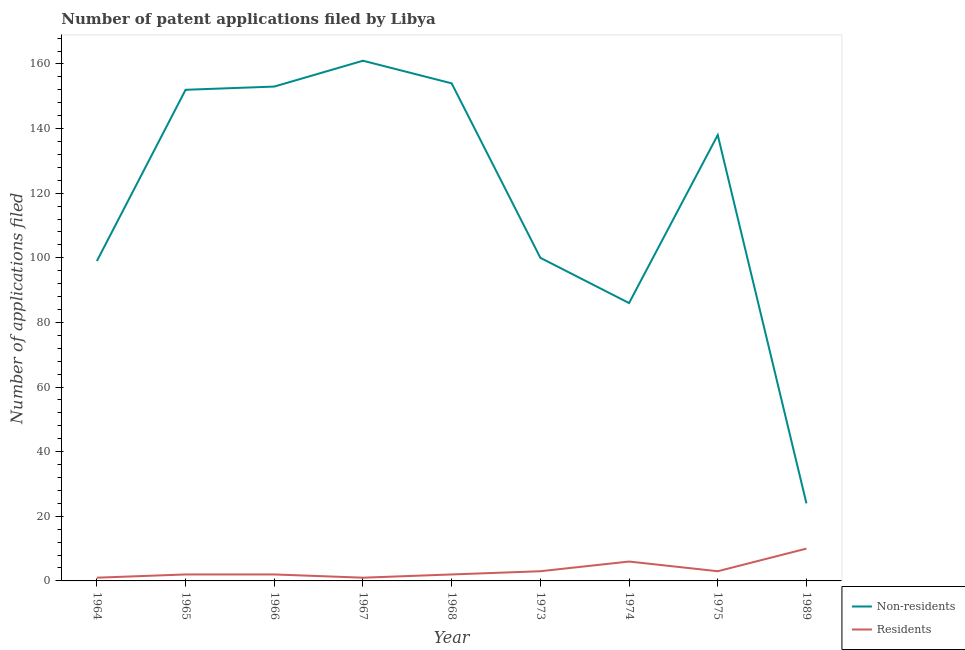How many different coloured lines are there?
Your answer should be compact. 2. Is the number of lines equal to the number of legend labels?
Offer a terse response. Yes. What is the number of patent applications by non residents in 1966?
Provide a short and direct response. 153. Across all years, what is the maximum number of patent applications by non residents?
Provide a succinct answer. 161. Across all years, what is the minimum number of patent applications by residents?
Provide a short and direct response. 1. In which year was the number of patent applications by non residents minimum?
Offer a very short reply. 1989. What is the total number of patent applications by residents in the graph?
Keep it short and to the point. 30. What is the difference between the number of patent applications by residents in 1966 and that in 1968?
Make the answer very short. 0. What is the difference between the number of patent applications by non residents in 1989 and the number of patent applications by residents in 1968?
Your answer should be compact. 22. What is the average number of patent applications by residents per year?
Give a very brief answer. 3.33. In the year 1965, what is the difference between the number of patent applications by non residents and number of patent applications by residents?
Provide a succinct answer. 150. What is the ratio of the number of patent applications by non residents in 1964 to that in 1974?
Your answer should be very brief. 1.15. Is the difference between the number of patent applications by residents in 1967 and 1974 greater than the difference between the number of patent applications by non residents in 1967 and 1974?
Your response must be concise. No. What is the difference between the highest and the second highest number of patent applications by residents?
Make the answer very short. 4. What is the difference between the highest and the lowest number of patent applications by non residents?
Your answer should be compact. 137. Is the sum of the number of patent applications by residents in 1964 and 1974 greater than the maximum number of patent applications by non residents across all years?
Your answer should be very brief. No. Does the number of patent applications by residents monotonically increase over the years?
Provide a succinct answer. No. Is the number of patent applications by residents strictly greater than the number of patent applications by non residents over the years?
Keep it short and to the point. No. Is the number of patent applications by non residents strictly less than the number of patent applications by residents over the years?
Your response must be concise. No. How many lines are there?
Provide a short and direct response. 2. How many years are there in the graph?
Provide a succinct answer. 9. How many legend labels are there?
Your answer should be very brief. 2. What is the title of the graph?
Provide a succinct answer. Number of patent applications filed by Libya. Does "Resident" appear as one of the legend labels in the graph?
Provide a succinct answer. No. What is the label or title of the Y-axis?
Provide a succinct answer. Number of applications filed. What is the Number of applications filed of Non-residents in 1964?
Keep it short and to the point. 99. What is the Number of applications filed of Residents in 1964?
Your answer should be compact. 1. What is the Number of applications filed of Non-residents in 1965?
Provide a succinct answer. 152. What is the Number of applications filed in Residents in 1965?
Provide a succinct answer. 2. What is the Number of applications filed in Non-residents in 1966?
Your answer should be very brief. 153. What is the Number of applications filed of Residents in 1966?
Your answer should be very brief. 2. What is the Number of applications filed in Non-residents in 1967?
Your answer should be compact. 161. What is the Number of applications filed of Residents in 1967?
Offer a terse response. 1. What is the Number of applications filed of Non-residents in 1968?
Ensure brevity in your answer.  154. What is the Number of applications filed in Residents in 1968?
Offer a terse response. 2. What is the Number of applications filed of Non-residents in 1973?
Offer a terse response. 100. What is the Number of applications filed in Residents in 1973?
Offer a very short reply. 3. What is the Number of applications filed in Residents in 1974?
Your answer should be very brief. 6. What is the Number of applications filed of Non-residents in 1975?
Provide a short and direct response. 138. What is the Number of applications filed in Residents in 1975?
Ensure brevity in your answer.  3. Across all years, what is the maximum Number of applications filed in Non-residents?
Give a very brief answer. 161. Across all years, what is the minimum Number of applications filed of Non-residents?
Keep it short and to the point. 24. What is the total Number of applications filed in Non-residents in the graph?
Give a very brief answer. 1067. What is the difference between the Number of applications filed of Non-residents in 1964 and that in 1965?
Provide a succinct answer. -53. What is the difference between the Number of applications filed in Residents in 1964 and that in 1965?
Make the answer very short. -1. What is the difference between the Number of applications filed of Non-residents in 1964 and that in 1966?
Provide a succinct answer. -54. What is the difference between the Number of applications filed in Residents in 1964 and that in 1966?
Give a very brief answer. -1. What is the difference between the Number of applications filed in Non-residents in 1964 and that in 1967?
Keep it short and to the point. -62. What is the difference between the Number of applications filed of Residents in 1964 and that in 1967?
Your answer should be very brief. 0. What is the difference between the Number of applications filed of Non-residents in 1964 and that in 1968?
Offer a very short reply. -55. What is the difference between the Number of applications filed of Residents in 1964 and that in 1968?
Provide a short and direct response. -1. What is the difference between the Number of applications filed of Non-residents in 1964 and that in 1973?
Offer a terse response. -1. What is the difference between the Number of applications filed of Residents in 1964 and that in 1973?
Give a very brief answer. -2. What is the difference between the Number of applications filed of Non-residents in 1964 and that in 1975?
Keep it short and to the point. -39. What is the difference between the Number of applications filed in Residents in 1964 and that in 1975?
Give a very brief answer. -2. What is the difference between the Number of applications filed of Non-residents in 1964 and that in 1989?
Offer a very short reply. 75. What is the difference between the Number of applications filed of Non-residents in 1965 and that in 1966?
Ensure brevity in your answer.  -1. What is the difference between the Number of applications filed in Non-residents in 1965 and that in 1967?
Keep it short and to the point. -9. What is the difference between the Number of applications filed in Non-residents in 1965 and that in 1968?
Your answer should be compact. -2. What is the difference between the Number of applications filed in Non-residents in 1965 and that in 1973?
Provide a short and direct response. 52. What is the difference between the Number of applications filed in Residents in 1965 and that in 1973?
Keep it short and to the point. -1. What is the difference between the Number of applications filed of Non-residents in 1965 and that in 1974?
Provide a succinct answer. 66. What is the difference between the Number of applications filed of Non-residents in 1965 and that in 1989?
Your response must be concise. 128. What is the difference between the Number of applications filed in Non-residents in 1966 and that in 1967?
Give a very brief answer. -8. What is the difference between the Number of applications filed in Residents in 1966 and that in 1967?
Your answer should be compact. 1. What is the difference between the Number of applications filed in Non-residents in 1966 and that in 1968?
Give a very brief answer. -1. What is the difference between the Number of applications filed in Residents in 1966 and that in 1968?
Keep it short and to the point. 0. What is the difference between the Number of applications filed in Non-residents in 1966 and that in 1973?
Make the answer very short. 53. What is the difference between the Number of applications filed in Residents in 1966 and that in 1973?
Provide a succinct answer. -1. What is the difference between the Number of applications filed in Residents in 1966 and that in 1974?
Provide a succinct answer. -4. What is the difference between the Number of applications filed of Non-residents in 1966 and that in 1989?
Make the answer very short. 129. What is the difference between the Number of applications filed in Residents in 1966 and that in 1989?
Offer a terse response. -8. What is the difference between the Number of applications filed in Non-residents in 1967 and that in 1968?
Provide a succinct answer. 7. What is the difference between the Number of applications filed in Residents in 1967 and that in 1968?
Ensure brevity in your answer.  -1. What is the difference between the Number of applications filed of Non-residents in 1967 and that in 1973?
Give a very brief answer. 61. What is the difference between the Number of applications filed in Residents in 1967 and that in 1973?
Offer a terse response. -2. What is the difference between the Number of applications filed in Residents in 1967 and that in 1974?
Offer a terse response. -5. What is the difference between the Number of applications filed of Residents in 1967 and that in 1975?
Ensure brevity in your answer.  -2. What is the difference between the Number of applications filed in Non-residents in 1967 and that in 1989?
Ensure brevity in your answer.  137. What is the difference between the Number of applications filed of Residents in 1967 and that in 1989?
Give a very brief answer. -9. What is the difference between the Number of applications filed in Non-residents in 1968 and that in 1973?
Give a very brief answer. 54. What is the difference between the Number of applications filed of Non-residents in 1968 and that in 1989?
Your response must be concise. 130. What is the difference between the Number of applications filed in Non-residents in 1973 and that in 1974?
Provide a succinct answer. 14. What is the difference between the Number of applications filed in Residents in 1973 and that in 1974?
Offer a terse response. -3. What is the difference between the Number of applications filed of Non-residents in 1973 and that in 1975?
Ensure brevity in your answer.  -38. What is the difference between the Number of applications filed of Non-residents in 1974 and that in 1975?
Give a very brief answer. -52. What is the difference between the Number of applications filed in Residents in 1974 and that in 1975?
Your response must be concise. 3. What is the difference between the Number of applications filed of Non-residents in 1974 and that in 1989?
Keep it short and to the point. 62. What is the difference between the Number of applications filed of Residents in 1974 and that in 1989?
Your response must be concise. -4. What is the difference between the Number of applications filed in Non-residents in 1975 and that in 1989?
Your response must be concise. 114. What is the difference between the Number of applications filed of Non-residents in 1964 and the Number of applications filed of Residents in 1965?
Your answer should be very brief. 97. What is the difference between the Number of applications filed in Non-residents in 1964 and the Number of applications filed in Residents in 1966?
Your answer should be compact. 97. What is the difference between the Number of applications filed in Non-residents in 1964 and the Number of applications filed in Residents in 1968?
Keep it short and to the point. 97. What is the difference between the Number of applications filed of Non-residents in 1964 and the Number of applications filed of Residents in 1973?
Make the answer very short. 96. What is the difference between the Number of applications filed of Non-residents in 1964 and the Number of applications filed of Residents in 1974?
Offer a very short reply. 93. What is the difference between the Number of applications filed in Non-residents in 1964 and the Number of applications filed in Residents in 1975?
Offer a terse response. 96. What is the difference between the Number of applications filed of Non-residents in 1964 and the Number of applications filed of Residents in 1989?
Make the answer very short. 89. What is the difference between the Number of applications filed of Non-residents in 1965 and the Number of applications filed of Residents in 1966?
Make the answer very short. 150. What is the difference between the Number of applications filed of Non-residents in 1965 and the Number of applications filed of Residents in 1967?
Keep it short and to the point. 151. What is the difference between the Number of applications filed in Non-residents in 1965 and the Number of applications filed in Residents in 1968?
Your response must be concise. 150. What is the difference between the Number of applications filed of Non-residents in 1965 and the Number of applications filed of Residents in 1973?
Offer a terse response. 149. What is the difference between the Number of applications filed of Non-residents in 1965 and the Number of applications filed of Residents in 1974?
Your answer should be very brief. 146. What is the difference between the Number of applications filed of Non-residents in 1965 and the Number of applications filed of Residents in 1975?
Keep it short and to the point. 149. What is the difference between the Number of applications filed of Non-residents in 1965 and the Number of applications filed of Residents in 1989?
Offer a terse response. 142. What is the difference between the Number of applications filed in Non-residents in 1966 and the Number of applications filed in Residents in 1967?
Provide a short and direct response. 152. What is the difference between the Number of applications filed in Non-residents in 1966 and the Number of applications filed in Residents in 1968?
Make the answer very short. 151. What is the difference between the Number of applications filed of Non-residents in 1966 and the Number of applications filed of Residents in 1973?
Provide a short and direct response. 150. What is the difference between the Number of applications filed in Non-residents in 1966 and the Number of applications filed in Residents in 1974?
Your answer should be compact. 147. What is the difference between the Number of applications filed of Non-residents in 1966 and the Number of applications filed of Residents in 1975?
Provide a short and direct response. 150. What is the difference between the Number of applications filed in Non-residents in 1966 and the Number of applications filed in Residents in 1989?
Offer a terse response. 143. What is the difference between the Number of applications filed in Non-residents in 1967 and the Number of applications filed in Residents in 1968?
Offer a terse response. 159. What is the difference between the Number of applications filed in Non-residents in 1967 and the Number of applications filed in Residents in 1973?
Give a very brief answer. 158. What is the difference between the Number of applications filed of Non-residents in 1967 and the Number of applications filed of Residents in 1974?
Keep it short and to the point. 155. What is the difference between the Number of applications filed of Non-residents in 1967 and the Number of applications filed of Residents in 1975?
Offer a very short reply. 158. What is the difference between the Number of applications filed of Non-residents in 1967 and the Number of applications filed of Residents in 1989?
Your answer should be compact. 151. What is the difference between the Number of applications filed in Non-residents in 1968 and the Number of applications filed in Residents in 1973?
Offer a terse response. 151. What is the difference between the Number of applications filed in Non-residents in 1968 and the Number of applications filed in Residents in 1974?
Offer a very short reply. 148. What is the difference between the Number of applications filed of Non-residents in 1968 and the Number of applications filed of Residents in 1975?
Your answer should be very brief. 151. What is the difference between the Number of applications filed in Non-residents in 1968 and the Number of applications filed in Residents in 1989?
Provide a short and direct response. 144. What is the difference between the Number of applications filed of Non-residents in 1973 and the Number of applications filed of Residents in 1974?
Offer a very short reply. 94. What is the difference between the Number of applications filed of Non-residents in 1973 and the Number of applications filed of Residents in 1975?
Your answer should be very brief. 97. What is the difference between the Number of applications filed in Non-residents in 1973 and the Number of applications filed in Residents in 1989?
Provide a short and direct response. 90. What is the difference between the Number of applications filed in Non-residents in 1975 and the Number of applications filed in Residents in 1989?
Offer a very short reply. 128. What is the average Number of applications filed in Non-residents per year?
Keep it short and to the point. 118.56. What is the average Number of applications filed in Residents per year?
Ensure brevity in your answer.  3.33. In the year 1964, what is the difference between the Number of applications filed in Non-residents and Number of applications filed in Residents?
Give a very brief answer. 98. In the year 1965, what is the difference between the Number of applications filed in Non-residents and Number of applications filed in Residents?
Make the answer very short. 150. In the year 1966, what is the difference between the Number of applications filed of Non-residents and Number of applications filed of Residents?
Give a very brief answer. 151. In the year 1967, what is the difference between the Number of applications filed of Non-residents and Number of applications filed of Residents?
Provide a succinct answer. 160. In the year 1968, what is the difference between the Number of applications filed of Non-residents and Number of applications filed of Residents?
Give a very brief answer. 152. In the year 1973, what is the difference between the Number of applications filed of Non-residents and Number of applications filed of Residents?
Ensure brevity in your answer.  97. In the year 1974, what is the difference between the Number of applications filed in Non-residents and Number of applications filed in Residents?
Keep it short and to the point. 80. In the year 1975, what is the difference between the Number of applications filed in Non-residents and Number of applications filed in Residents?
Ensure brevity in your answer.  135. In the year 1989, what is the difference between the Number of applications filed in Non-residents and Number of applications filed in Residents?
Your answer should be compact. 14. What is the ratio of the Number of applications filed of Non-residents in 1964 to that in 1965?
Make the answer very short. 0.65. What is the ratio of the Number of applications filed of Non-residents in 1964 to that in 1966?
Provide a succinct answer. 0.65. What is the ratio of the Number of applications filed in Residents in 1964 to that in 1966?
Your answer should be very brief. 0.5. What is the ratio of the Number of applications filed in Non-residents in 1964 to that in 1967?
Give a very brief answer. 0.61. What is the ratio of the Number of applications filed of Non-residents in 1964 to that in 1968?
Provide a succinct answer. 0.64. What is the ratio of the Number of applications filed of Non-residents in 1964 to that in 1973?
Ensure brevity in your answer.  0.99. What is the ratio of the Number of applications filed in Residents in 1964 to that in 1973?
Your answer should be very brief. 0.33. What is the ratio of the Number of applications filed of Non-residents in 1964 to that in 1974?
Provide a succinct answer. 1.15. What is the ratio of the Number of applications filed of Non-residents in 1964 to that in 1975?
Make the answer very short. 0.72. What is the ratio of the Number of applications filed in Non-residents in 1964 to that in 1989?
Your answer should be compact. 4.12. What is the ratio of the Number of applications filed in Non-residents in 1965 to that in 1967?
Provide a short and direct response. 0.94. What is the ratio of the Number of applications filed of Residents in 1965 to that in 1967?
Keep it short and to the point. 2. What is the ratio of the Number of applications filed in Non-residents in 1965 to that in 1973?
Keep it short and to the point. 1.52. What is the ratio of the Number of applications filed of Residents in 1965 to that in 1973?
Keep it short and to the point. 0.67. What is the ratio of the Number of applications filed in Non-residents in 1965 to that in 1974?
Your answer should be compact. 1.77. What is the ratio of the Number of applications filed in Residents in 1965 to that in 1974?
Provide a short and direct response. 0.33. What is the ratio of the Number of applications filed of Non-residents in 1965 to that in 1975?
Ensure brevity in your answer.  1.1. What is the ratio of the Number of applications filed in Residents in 1965 to that in 1975?
Provide a succinct answer. 0.67. What is the ratio of the Number of applications filed of Non-residents in 1965 to that in 1989?
Your response must be concise. 6.33. What is the ratio of the Number of applications filed of Non-residents in 1966 to that in 1967?
Ensure brevity in your answer.  0.95. What is the ratio of the Number of applications filed of Non-residents in 1966 to that in 1973?
Your response must be concise. 1.53. What is the ratio of the Number of applications filed of Residents in 1966 to that in 1973?
Provide a succinct answer. 0.67. What is the ratio of the Number of applications filed in Non-residents in 1966 to that in 1974?
Your answer should be compact. 1.78. What is the ratio of the Number of applications filed in Residents in 1966 to that in 1974?
Offer a terse response. 0.33. What is the ratio of the Number of applications filed of Non-residents in 1966 to that in 1975?
Your response must be concise. 1.11. What is the ratio of the Number of applications filed in Non-residents in 1966 to that in 1989?
Provide a short and direct response. 6.38. What is the ratio of the Number of applications filed in Residents in 1966 to that in 1989?
Your answer should be very brief. 0.2. What is the ratio of the Number of applications filed in Non-residents in 1967 to that in 1968?
Ensure brevity in your answer.  1.05. What is the ratio of the Number of applications filed in Residents in 1967 to that in 1968?
Give a very brief answer. 0.5. What is the ratio of the Number of applications filed of Non-residents in 1967 to that in 1973?
Make the answer very short. 1.61. What is the ratio of the Number of applications filed of Residents in 1967 to that in 1973?
Your answer should be very brief. 0.33. What is the ratio of the Number of applications filed in Non-residents in 1967 to that in 1974?
Offer a very short reply. 1.87. What is the ratio of the Number of applications filed in Residents in 1967 to that in 1974?
Provide a short and direct response. 0.17. What is the ratio of the Number of applications filed of Non-residents in 1967 to that in 1975?
Offer a terse response. 1.17. What is the ratio of the Number of applications filed in Non-residents in 1967 to that in 1989?
Make the answer very short. 6.71. What is the ratio of the Number of applications filed in Non-residents in 1968 to that in 1973?
Your answer should be very brief. 1.54. What is the ratio of the Number of applications filed of Residents in 1968 to that in 1973?
Offer a terse response. 0.67. What is the ratio of the Number of applications filed in Non-residents in 1968 to that in 1974?
Your answer should be very brief. 1.79. What is the ratio of the Number of applications filed in Non-residents in 1968 to that in 1975?
Your response must be concise. 1.12. What is the ratio of the Number of applications filed in Residents in 1968 to that in 1975?
Provide a succinct answer. 0.67. What is the ratio of the Number of applications filed of Non-residents in 1968 to that in 1989?
Keep it short and to the point. 6.42. What is the ratio of the Number of applications filed in Residents in 1968 to that in 1989?
Offer a very short reply. 0.2. What is the ratio of the Number of applications filed in Non-residents in 1973 to that in 1974?
Provide a short and direct response. 1.16. What is the ratio of the Number of applications filed in Residents in 1973 to that in 1974?
Your answer should be compact. 0.5. What is the ratio of the Number of applications filed in Non-residents in 1973 to that in 1975?
Make the answer very short. 0.72. What is the ratio of the Number of applications filed of Non-residents in 1973 to that in 1989?
Ensure brevity in your answer.  4.17. What is the ratio of the Number of applications filed of Residents in 1973 to that in 1989?
Your answer should be very brief. 0.3. What is the ratio of the Number of applications filed in Non-residents in 1974 to that in 1975?
Your response must be concise. 0.62. What is the ratio of the Number of applications filed in Residents in 1974 to that in 1975?
Give a very brief answer. 2. What is the ratio of the Number of applications filed in Non-residents in 1974 to that in 1989?
Provide a succinct answer. 3.58. What is the ratio of the Number of applications filed in Non-residents in 1975 to that in 1989?
Your answer should be very brief. 5.75. What is the difference between the highest and the second highest Number of applications filed of Residents?
Give a very brief answer. 4. What is the difference between the highest and the lowest Number of applications filed in Non-residents?
Ensure brevity in your answer.  137. 